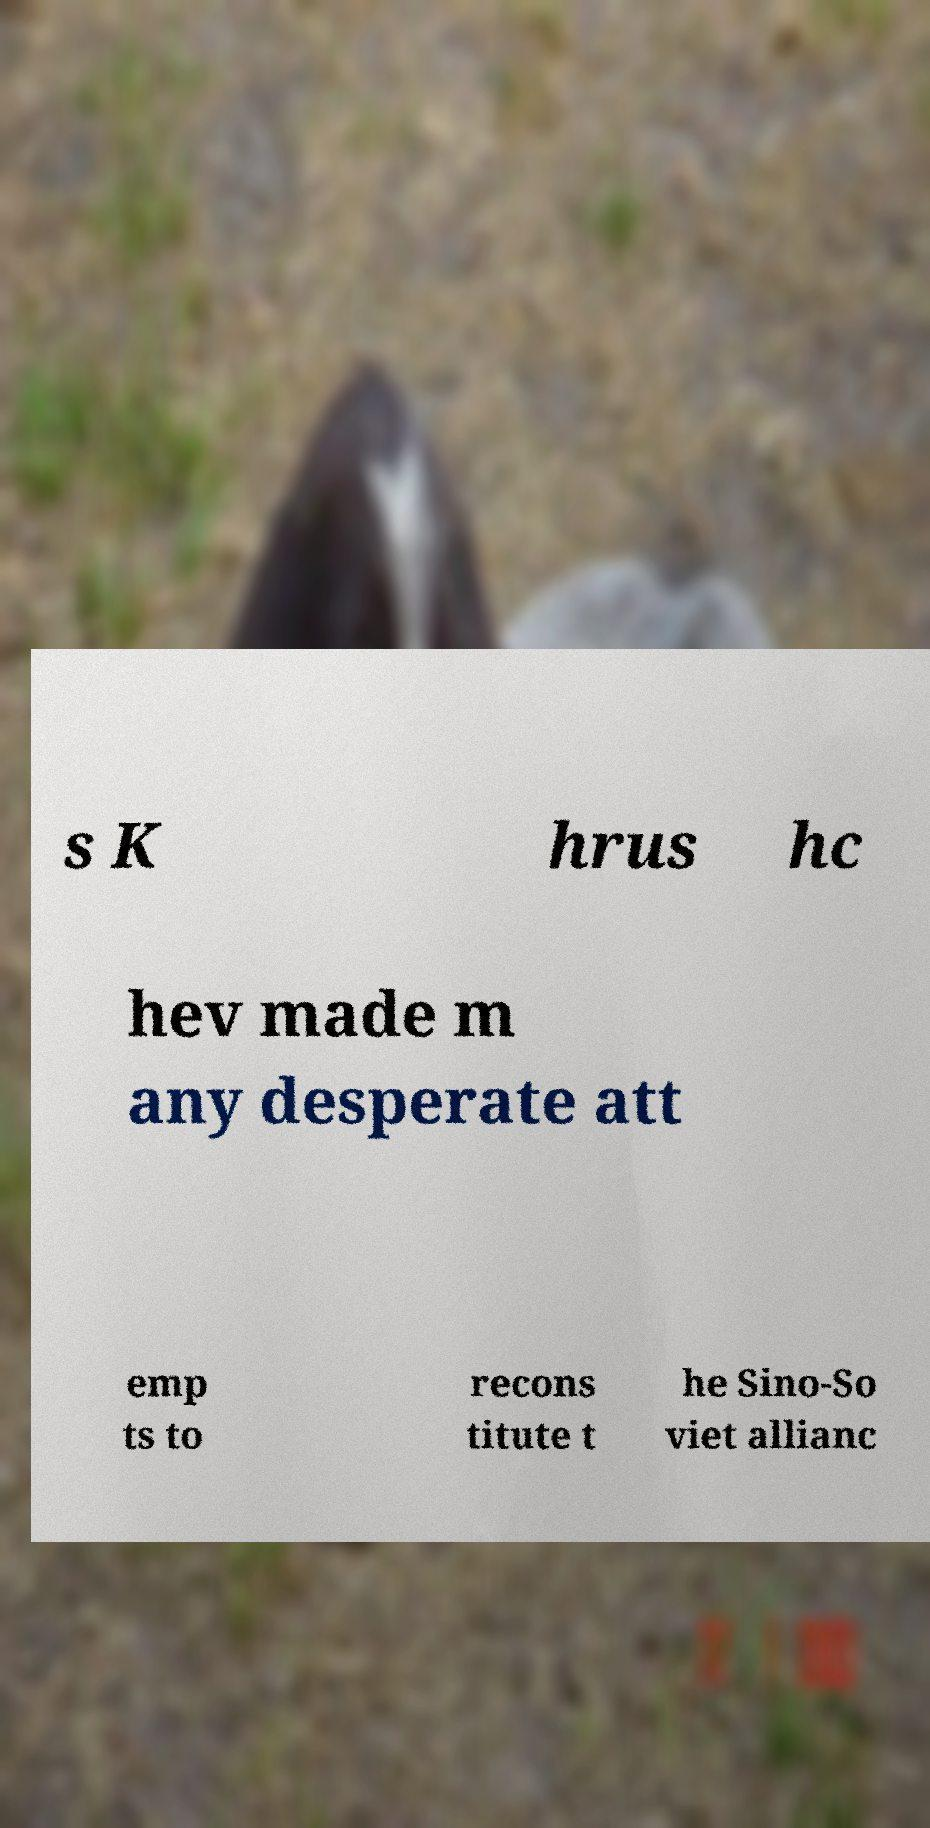Please read and relay the text visible in this image. What does it say? s K hrus hc hev made m any desperate att emp ts to recons titute t he Sino-So viet allianc 